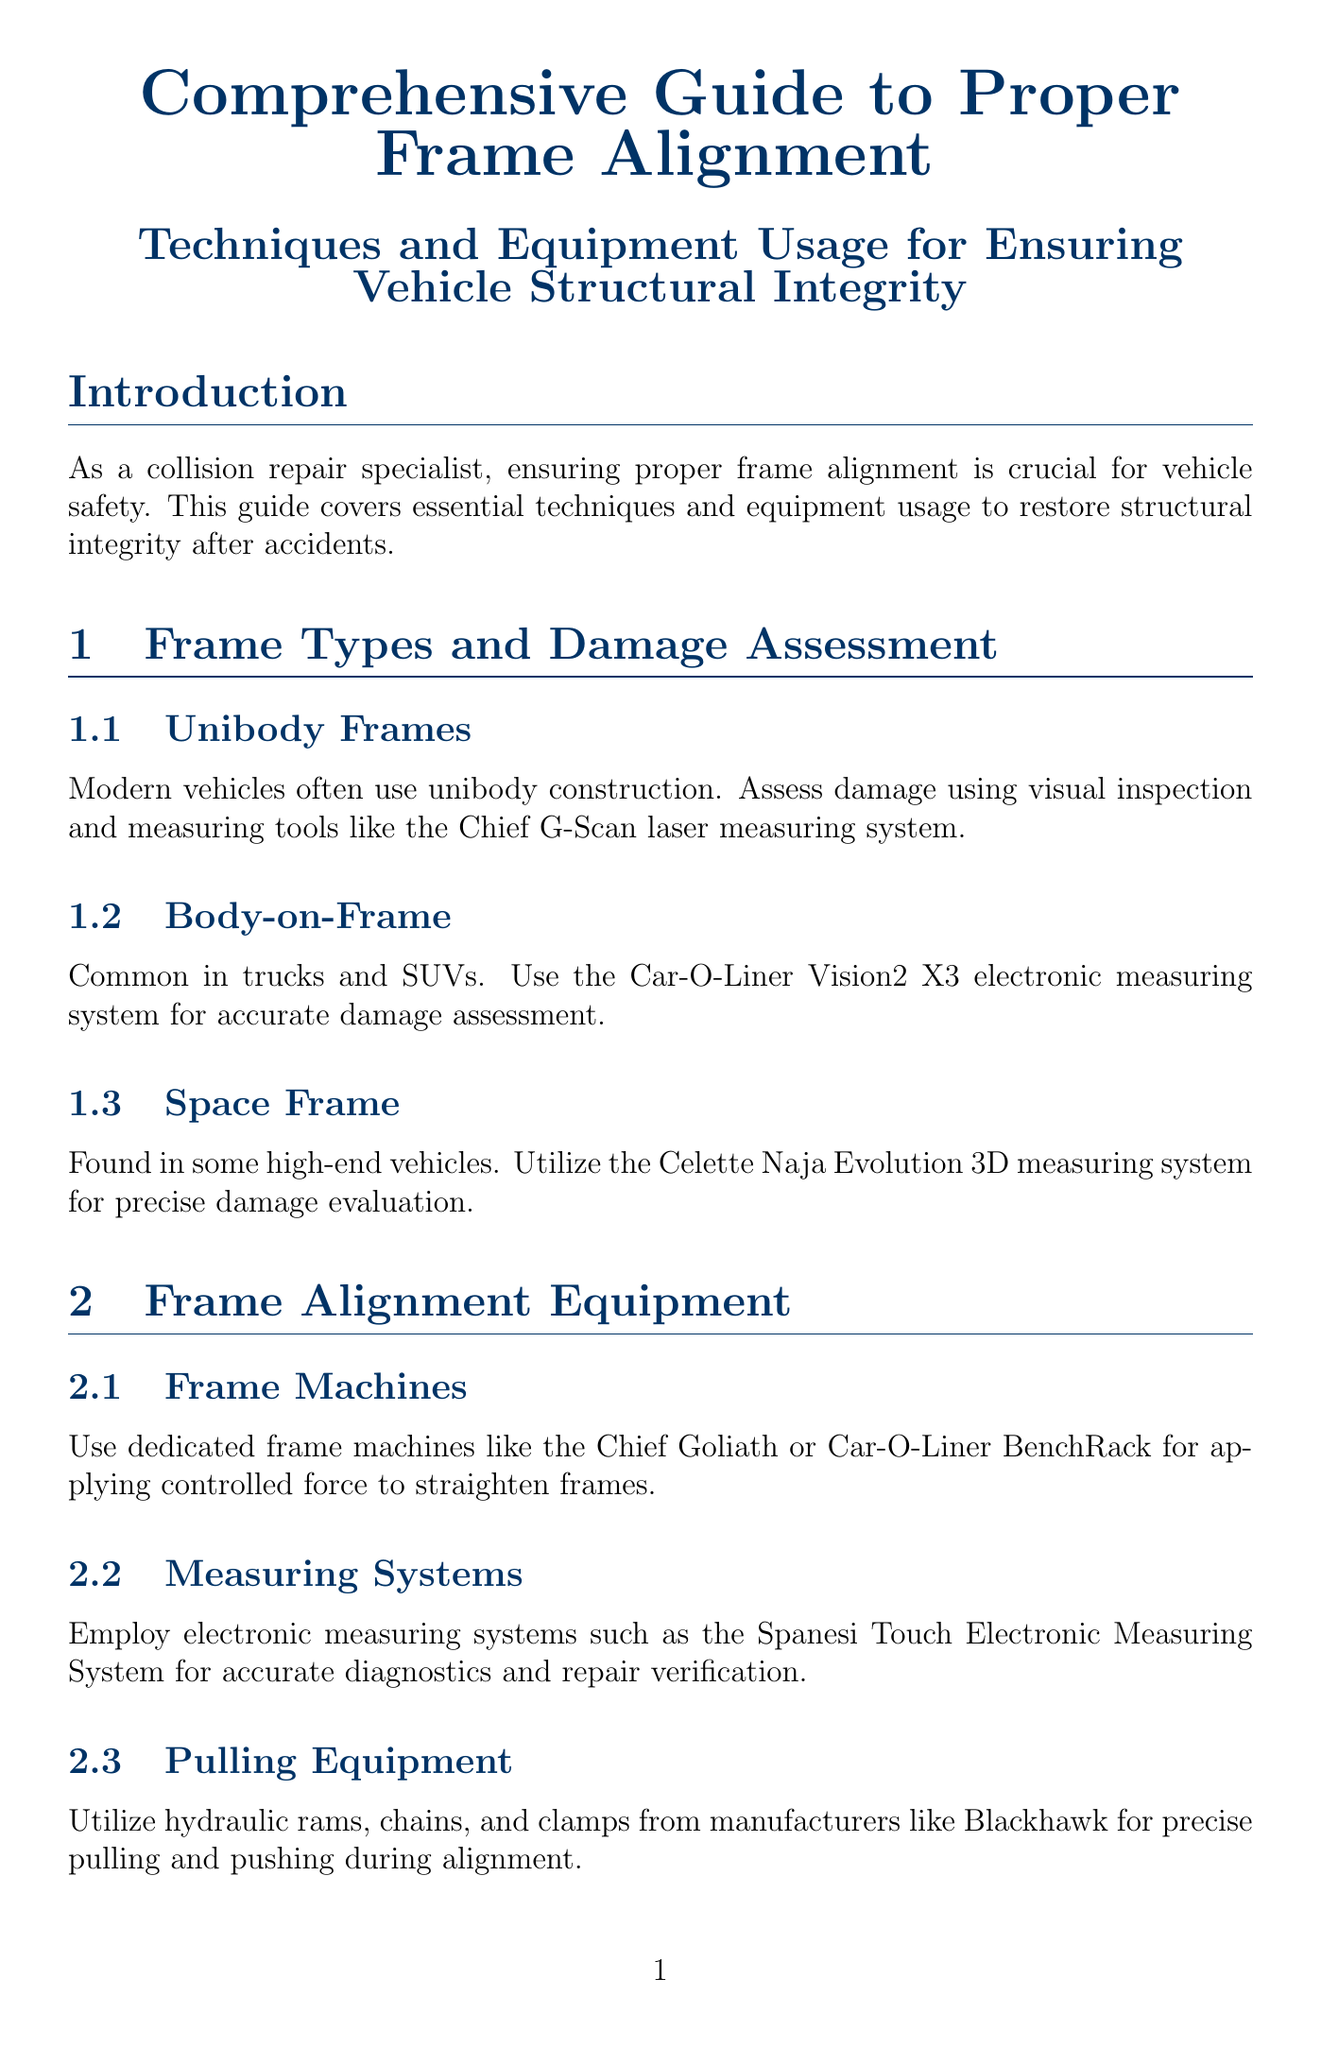What is the main focus of the guide? The guide emphasizes the importance of frame alignment for vehicle safety and structural integrity.
Answer: vehicle safety What measuring system is recommended for unibody frames? The guide specifies using the Chief G-Scan laser measuring system for assessing unibody frames.
Answer: Chief G-Scan Which type of equipment should be used for applying force to straighten frames? The document recommends dedicated frame machines like the Chief Goliath or Car-O-Liner BenchRack for this purpose.
Answer: Chief Goliath What technique is advised before major pulls? Controlled force should be used to relieve stress in the frame.
Answer: stress relieving What system is used for final 3D measurement verification? The Car-O-Tronic Vision2 X3 system is used for this final verification process.
Answer: Car-O-Tronic Vision2 X3 What is the purpose of generating detailed reports? The purpose is for customer assurance and legal compliance.
Answer: legal compliance Why should heat be applied before pulling? Oxyacetylene torches are used to heat areas for easier reshaping of high-strength steel components.
Answer: easier reshaping What should be prioritized to maintain vehicle crash worthiness? Safety procedures must be followed and necessary components repaired or replaced.
Answer: safety procedures 